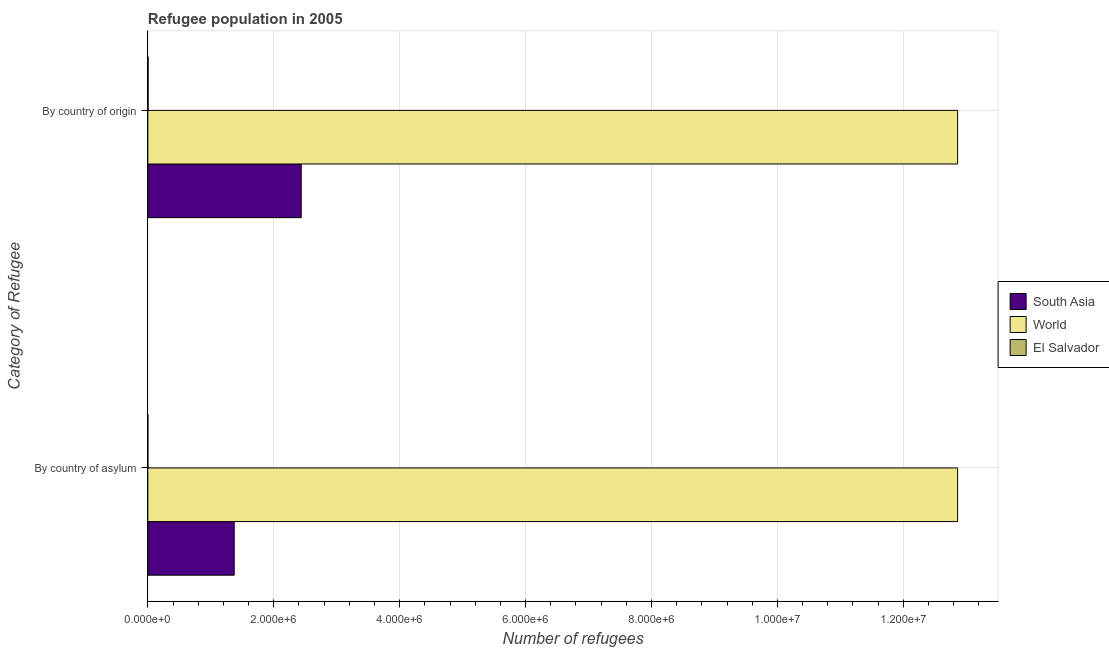How many groups of bars are there?
Make the answer very short. 2. Are the number of bars per tick equal to the number of legend labels?
Provide a succinct answer. Yes. How many bars are there on the 1st tick from the top?
Give a very brief answer. 3. How many bars are there on the 2nd tick from the bottom?
Give a very brief answer. 3. What is the label of the 2nd group of bars from the top?
Your response must be concise. By country of asylum. What is the number of refugees by country of origin in South Asia?
Your response must be concise. 2.44e+06. Across all countries, what is the maximum number of refugees by country of origin?
Your response must be concise. 1.29e+07. Across all countries, what is the minimum number of refugees by country of origin?
Offer a terse response. 4281. In which country was the number of refugees by country of asylum maximum?
Provide a short and direct response. World. In which country was the number of refugees by country of asylum minimum?
Make the answer very short. El Salvador. What is the total number of refugees by country of origin in the graph?
Make the answer very short. 1.53e+07. What is the difference between the number of refugees by country of asylum in South Asia and that in El Salvador?
Offer a terse response. 1.37e+06. What is the difference between the number of refugees by country of asylum in El Salvador and the number of refugees by country of origin in World?
Offer a very short reply. -1.29e+07. What is the average number of refugees by country of asylum per country?
Keep it short and to the point. 4.75e+06. What is the difference between the number of refugees by country of asylum and number of refugees by country of origin in South Asia?
Your answer should be very brief. -1.06e+06. In how many countries, is the number of refugees by country of origin greater than 1600000 ?
Offer a very short reply. 2. What is the ratio of the number of refugees by country of asylum in World to that in El Salvador?
Offer a very short reply. 2.63e+05. What does the 1st bar from the top in By country of asylum represents?
Your answer should be compact. El Salvador. What does the 1st bar from the bottom in By country of asylum represents?
Keep it short and to the point. South Asia. How many bars are there?
Offer a terse response. 6. How many countries are there in the graph?
Provide a short and direct response. 3. What is the difference between two consecutive major ticks on the X-axis?
Your response must be concise. 2.00e+06. Are the values on the major ticks of X-axis written in scientific E-notation?
Give a very brief answer. Yes. Does the graph contain grids?
Your answer should be compact. Yes. What is the title of the graph?
Your answer should be very brief. Refugee population in 2005. What is the label or title of the X-axis?
Keep it short and to the point. Number of refugees. What is the label or title of the Y-axis?
Offer a terse response. Category of Refugee. What is the Number of refugees in South Asia in By country of asylum?
Give a very brief answer. 1.37e+06. What is the Number of refugees of World in By country of asylum?
Your answer should be very brief. 1.29e+07. What is the Number of refugees of South Asia in By country of origin?
Give a very brief answer. 2.44e+06. What is the Number of refugees of World in By country of origin?
Offer a terse response. 1.29e+07. What is the Number of refugees of El Salvador in By country of origin?
Offer a terse response. 4281. Across all Category of Refugee, what is the maximum Number of refugees in South Asia?
Provide a succinct answer. 2.44e+06. Across all Category of Refugee, what is the maximum Number of refugees in World?
Provide a succinct answer. 1.29e+07. Across all Category of Refugee, what is the maximum Number of refugees in El Salvador?
Make the answer very short. 4281. Across all Category of Refugee, what is the minimum Number of refugees in South Asia?
Make the answer very short. 1.37e+06. Across all Category of Refugee, what is the minimum Number of refugees in World?
Provide a succinct answer. 1.29e+07. What is the total Number of refugees in South Asia in the graph?
Offer a very short reply. 3.81e+06. What is the total Number of refugees of World in the graph?
Offer a very short reply. 2.57e+07. What is the total Number of refugees in El Salvador in the graph?
Ensure brevity in your answer.  4330. What is the difference between the Number of refugees in South Asia in By country of asylum and that in By country of origin?
Make the answer very short. -1.06e+06. What is the difference between the Number of refugees in El Salvador in By country of asylum and that in By country of origin?
Your answer should be very brief. -4232. What is the difference between the Number of refugees of South Asia in By country of asylum and the Number of refugees of World in By country of origin?
Your answer should be compact. -1.15e+07. What is the difference between the Number of refugees in South Asia in By country of asylum and the Number of refugees in El Salvador in By country of origin?
Keep it short and to the point. 1.37e+06. What is the difference between the Number of refugees of World in By country of asylum and the Number of refugees of El Salvador in By country of origin?
Offer a very short reply. 1.29e+07. What is the average Number of refugees of South Asia per Category of Refugee?
Your response must be concise. 1.90e+06. What is the average Number of refugees of World per Category of Refugee?
Your answer should be very brief. 1.29e+07. What is the average Number of refugees of El Salvador per Category of Refugee?
Provide a short and direct response. 2165. What is the difference between the Number of refugees in South Asia and Number of refugees in World in By country of asylum?
Make the answer very short. -1.15e+07. What is the difference between the Number of refugees in South Asia and Number of refugees in El Salvador in By country of asylum?
Provide a short and direct response. 1.37e+06. What is the difference between the Number of refugees of World and Number of refugees of El Salvador in By country of asylum?
Provide a short and direct response. 1.29e+07. What is the difference between the Number of refugees in South Asia and Number of refugees in World in By country of origin?
Your response must be concise. -1.04e+07. What is the difference between the Number of refugees in South Asia and Number of refugees in El Salvador in By country of origin?
Keep it short and to the point. 2.43e+06. What is the difference between the Number of refugees of World and Number of refugees of El Salvador in By country of origin?
Keep it short and to the point. 1.29e+07. What is the ratio of the Number of refugees in South Asia in By country of asylum to that in By country of origin?
Keep it short and to the point. 0.56. What is the ratio of the Number of refugees in El Salvador in By country of asylum to that in By country of origin?
Give a very brief answer. 0.01. What is the difference between the highest and the second highest Number of refugees of South Asia?
Offer a terse response. 1.06e+06. What is the difference between the highest and the second highest Number of refugees in El Salvador?
Your answer should be very brief. 4232. What is the difference between the highest and the lowest Number of refugees in South Asia?
Your answer should be very brief. 1.06e+06. What is the difference between the highest and the lowest Number of refugees of El Salvador?
Your answer should be compact. 4232. 